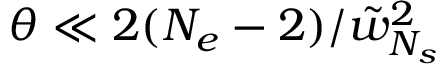<formula> <loc_0><loc_0><loc_500><loc_500>\theta \ll 2 ( N _ { e } - 2 ) / \tilde { w } _ { N _ { s } } ^ { 2 }</formula> 